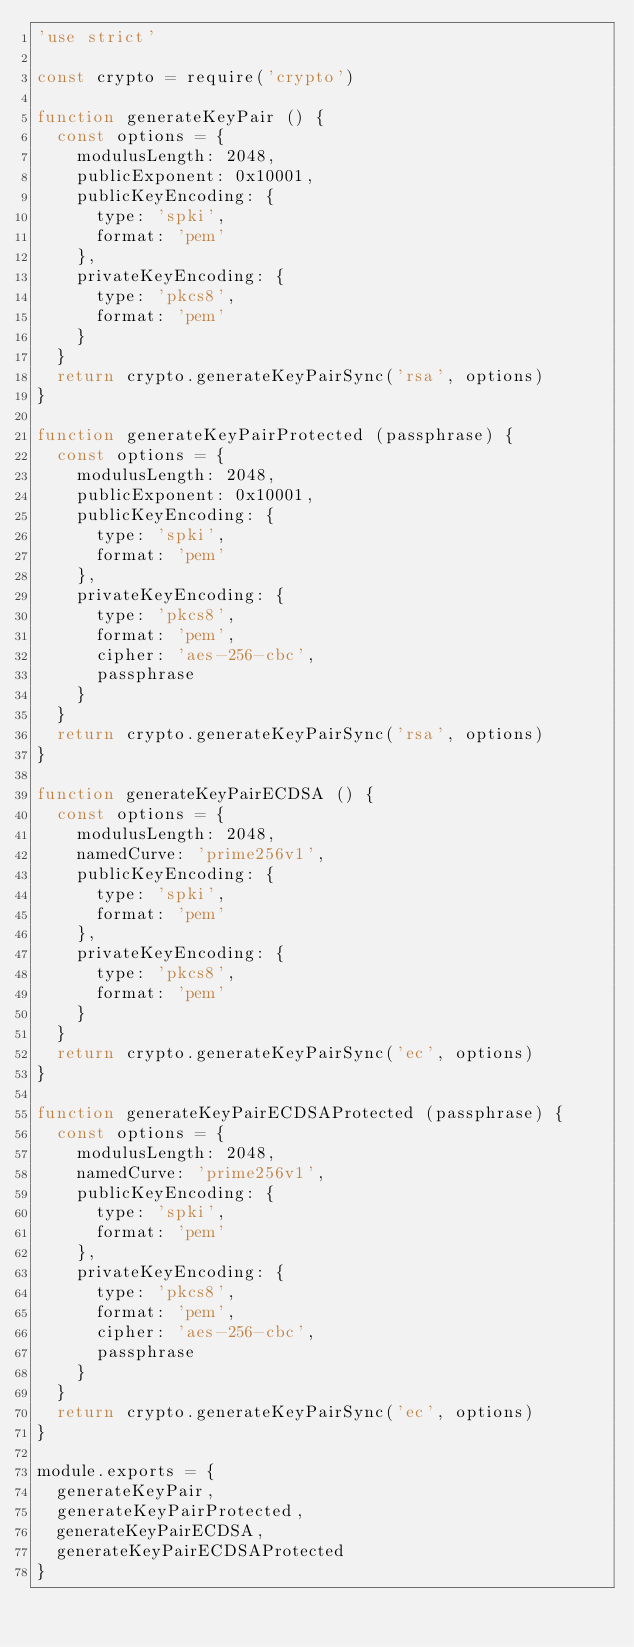<code> <loc_0><loc_0><loc_500><loc_500><_JavaScript_>'use strict'

const crypto = require('crypto')

function generateKeyPair () {
  const options = {
    modulusLength: 2048,
    publicExponent: 0x10001,
    publicKeyEncoding: {
      type: 'spki',
      format: 'pem'
    },
    privateKeyEncoding: {
      type: 'pkcs8',
      format: 'pem'
    }
  }
  return crypto.generateKeyPairSync('rsa', options)
}

function generateKeyPairProtected (passphrase) {
  const options = {
    modulusLength: 2048,
    publicExponent: 0x10001,
    publicKeyEncoding: {
      type: 'spki',
      format: 'pem'
    },
    privateKeyEncoding: {
      type: 'pkcs8',
      format: 'pem',
      cipher: 'aes-256-cbc',
      passphrase
    }
  }
  return crypto.generateKeyPairSync('rsa', options)
}

function generateKeyPairECDSA () {
  const options = {
    modulusLength: 2048,
    namedCurve: 'prime256v1',
    publicKeyEncoding: {
      type: 'spki',
      format: 'pem'
    },
    privateKeyEncoding: {
      type: 'pkcs8',
      format: 'pem'
    }
  }
  return crypto.generateKeyPairSync('ec', options)
}

function generateKeyPairECDSAProtected (passphrase) {
  const options = {
    modulusLength: 2048,
    namedCurve: 'prime256v1',
    publicKeyEncoding: {
      type: 'spki',
      format: 'pem'
    },
    privateKeyEncoding: {
      type: 'pkcs8',
      format: 'pem',
      cipher: 'aes-256-cbc',
      passphrase
    }
  }
  return crypto.generateKeyPairSync('ec', options)
}

module.exports = {
  generateKeyPair,
  generateKeyPairProtected,
  generateKeyPairECDSA,
  generateKeyPairECDSAProtected
}
</code> 